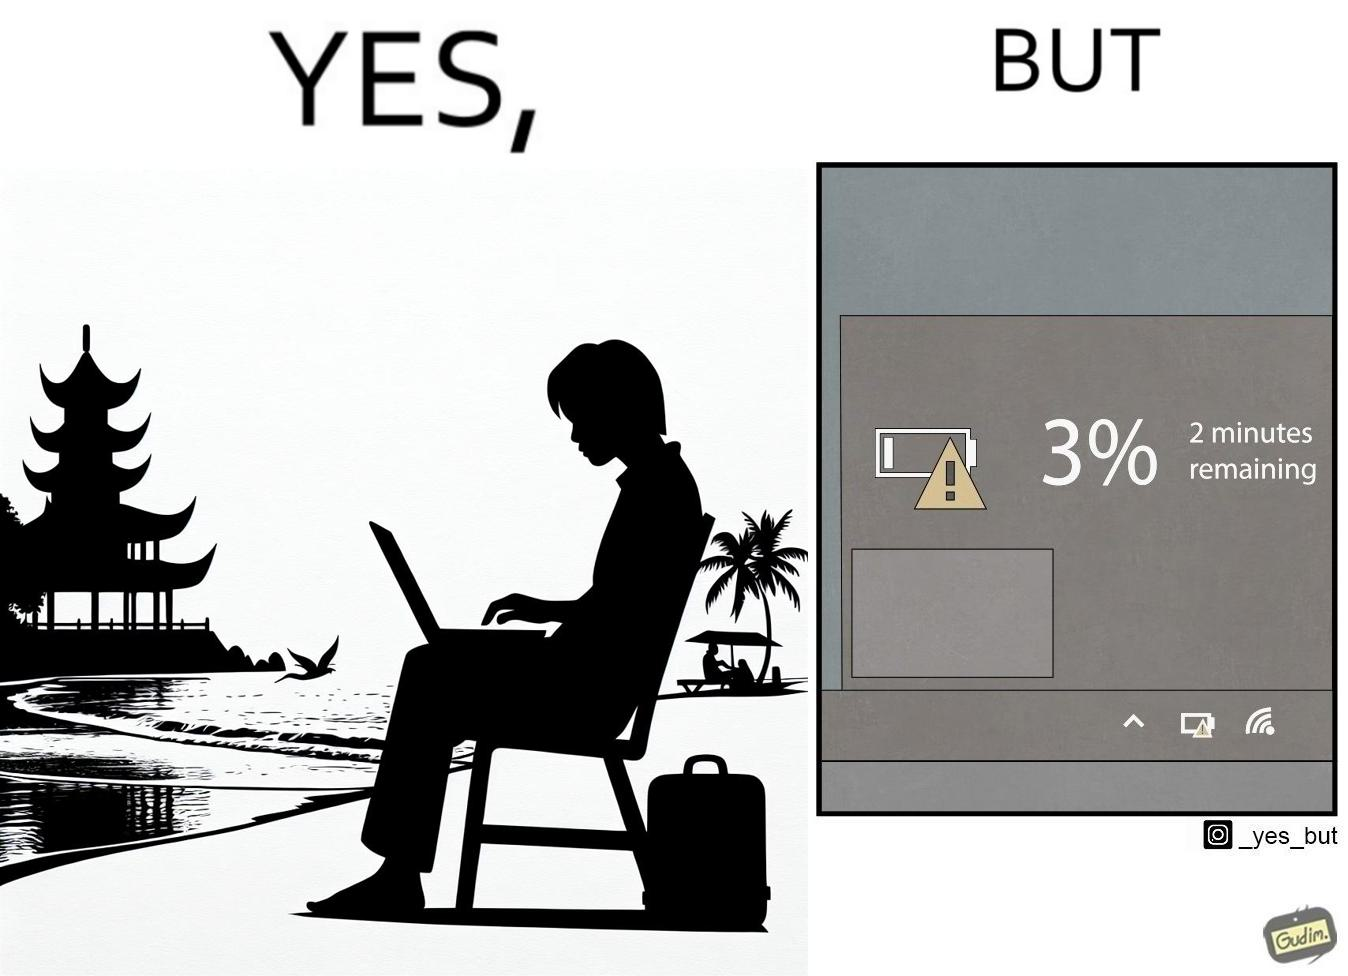Describe what you see in the left and right parts of this image. In the left part of the image: A person sitting in a chair in a beach by the sea shore while working on a laptop. In the right part of the image: Low charge of battery, showing 3% charge, and an estimated time of 2 minutes remaining until the device switches off due to lack of battery charge. 